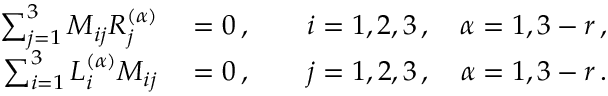Convert formula to latex. <formula><loc_0><loc_0><loc_500><loc_500>\begin{array} { r l } { \sum _ { j = 1 } ^ { 3 } M _ { i j } R _ { j } ^ { ( \alpha ) } } & = 0 \, , \quad i = 1 , 2 , 3 \, , \quad \alpha = 1 , 3 - r \, , } \\ { \sum _ { i = 1 } ^ { 3 } L _ { i } ^ { ( \alpha ) } M _ { i j } } & = 0 \, , \quad j = 1 , 2 , 3 \, , \quad \alpha = 1 , 3 - r \, . } \end{array}</formula> 